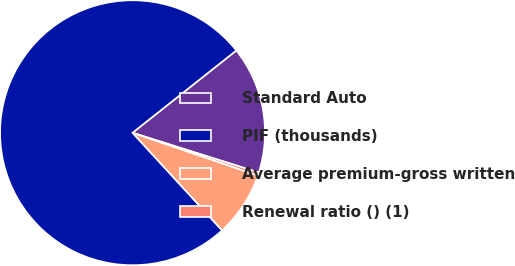Convert chart. <chart><loc_0><loc_0><loc_500><loc_500><pie_chart><fcel>Standard Auto<fcel>PIF (thousands)<fcel>Average premium-gross written<fcel>Renewal ratio () (1)<nl><fcel>15.53%<fcel>76.15%<fcel>7.95%<fcel>0.37%<nl></chart> 